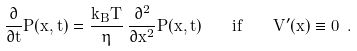Convert formula to latex. <formula><loc_0><loc_0><loc_500><loc_500>\frac { \partial } { \partial t } P ( x , t ) = \frac { k _ { B } T } { \eta } \, \frac { \partial ^ { 2 } } { \partial x ^ { 2 } } P ( x , t ) \quad i f \quad V ^ { \prime } ( x ) \equiv 0 \ .</formula> 